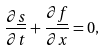Convert formula to latex. <formula><loc_0><loc_0><loc_500><loc_500>\frac { \partial \underline { s } } { \partial t } + \frac { \partial \underline { f } } { \partial x } = 0 ,</formula> 